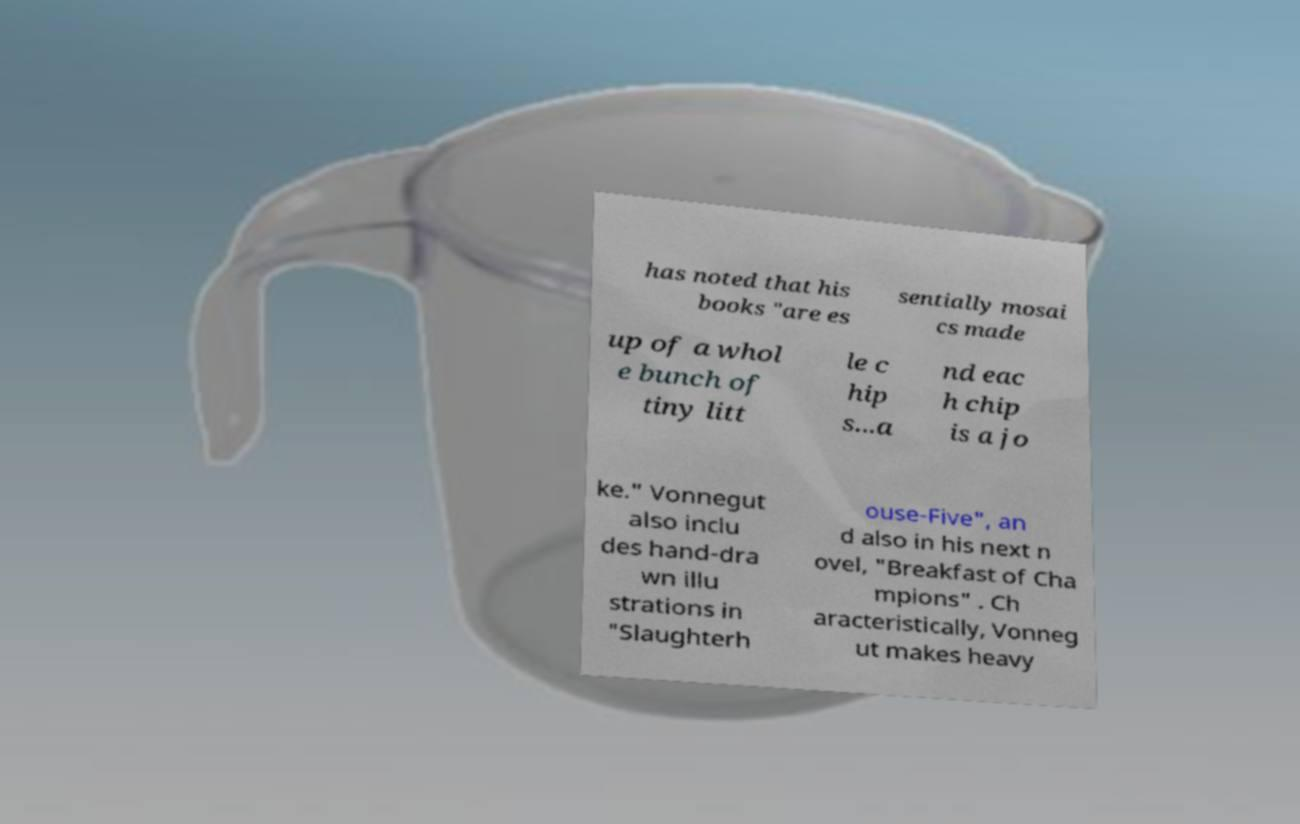I need the written content from this picture converted into text. Can you do that? has noted that his books "are es sentially mosai cs made up of a whol e bunch of tiny litt le c hip s...a nd eac h chip is a jo ke." Vonnegut also inclu des hand-dra wn illu strations in "Slaughterh ouse-Five", an d also in his next n ovel, "Breakfast of Cha mpions" . Ch aracteristically, Vonneg ut makes heavy 